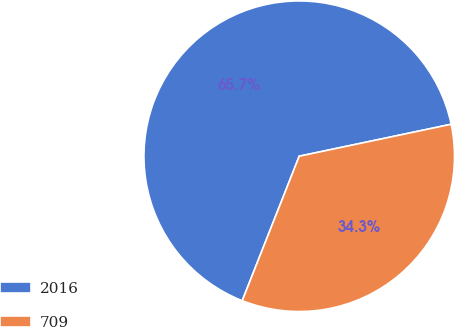Convert chart. <chart><loc_0><loc_0><loc_500><loc_500><pie_chart><fcel>2016<fcel>709<nl><fcel>65.72%<fcel>34.28%<nl></chart> 